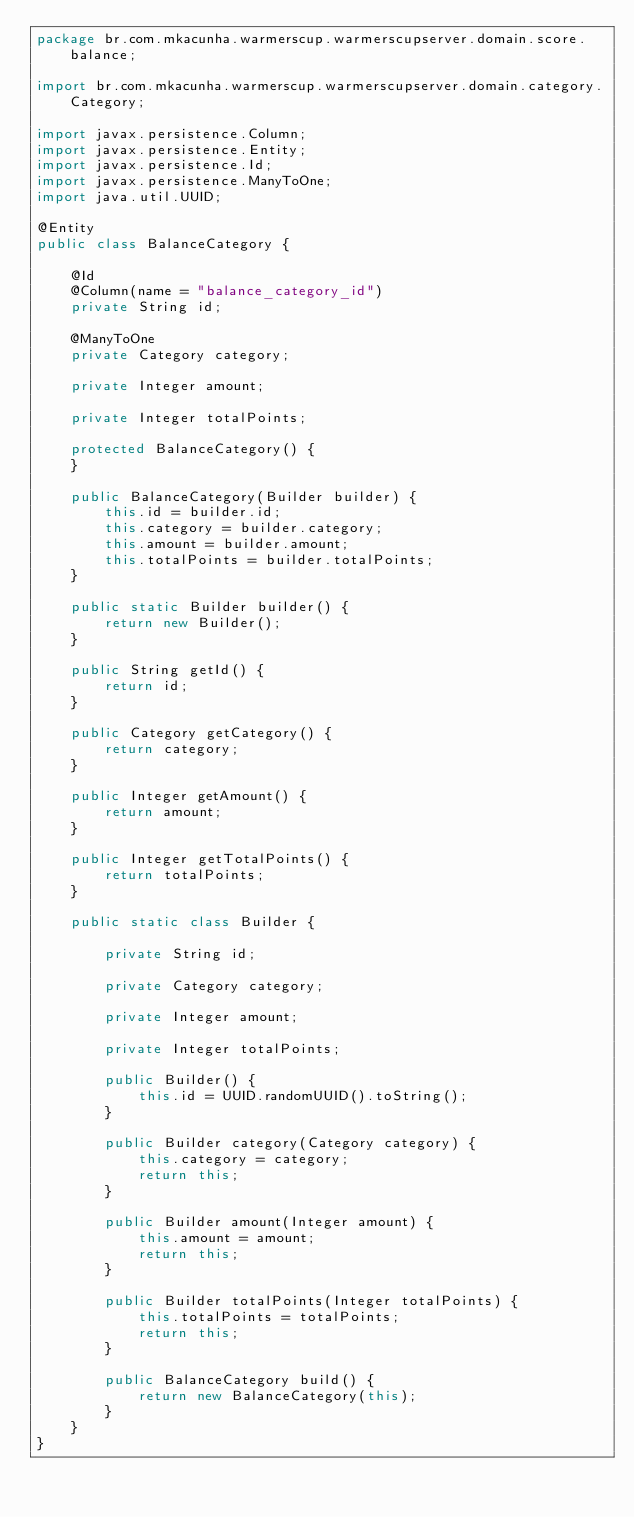<code> <loc_0><loc_0><loc_500><loc_500><_Java_>package br.com.mkacunha.warmerscup.warmerscupserver.domain.score.balance;

import br.com.mkacunha.warmerscup.warmerscupserver.domain.category.Category;

import javax.persistence.Column;
import javax.persistence.Entity;
import javax.persistence.Id;
import javax.persistence.ManyToOne;
import java.util.UUID;

@Entity
public class BalanceCategory {

    @Id
    @Column(name = "balance_category_id")
    private String id;

    @ManyToOne
    private Category category;

    private Integer amount;

    private Integer totalPoints;

    protected BalanceCategory() {
    }

    public BalanceCategory(Builder builder) {
        this.id = builder.id;
        this.category = builder.category;
        this.amount = builder.amount;
        this.totalPoints = builder.totalPoints;
    }

    public static Builder builder() {
        return new Builder();
    }

    public String getId() {
        return id;
    }

    public Category getCategory() {
        return category;
    }

    public Integer getAmount() {
        return amount;
    }

    public Integer getTotalPoints() {
        return totalPoints;
    }

    public static class Builder {

        private String id;

        private Category category;

        private Integer amount;

        private Integer totalPoints;

        public Builder() {
            this.id = UUID.randomUUID().toString();
        }

        public Builder category(Category category) {
            this.category = category;
            return this;
        }

        public Builder amount(Integer amount) {
            this.amount = amount;
            return this;
        }

        public Builder totalPoints(Integer totalPoints) {
            this.totalPoints = totalPoints;
            return this;
        }

        public BalanceCategory build() {
            return new BalanceCategory(this);
        }
    }
}
</code> 